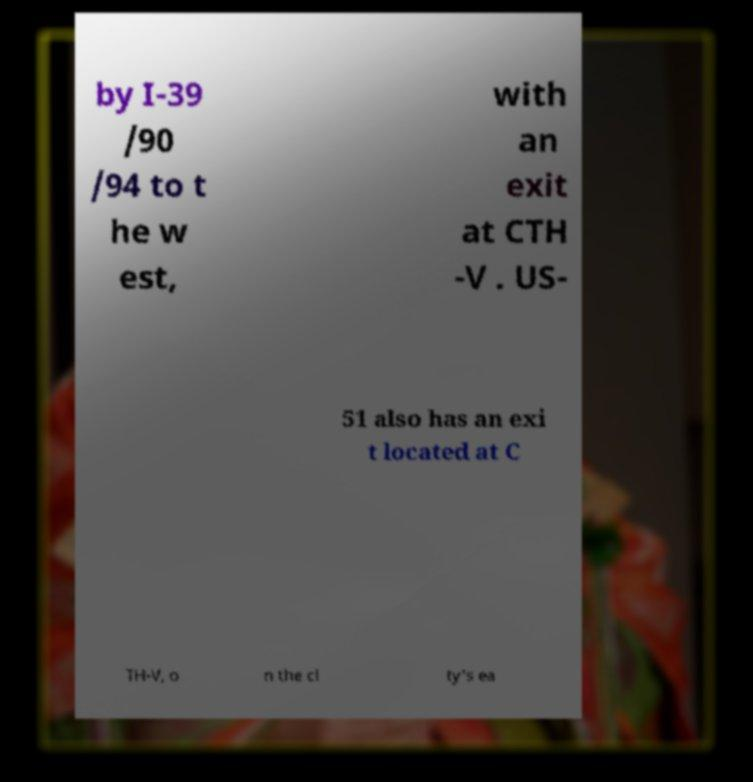Could you assist in decoding the text presented in this image and type it out clearly? by I-39 /90 /94 to t he w est, with an exit at CTH -V . US- 51 also has an exi t located at C TH-V, o n the ci ty's ea 